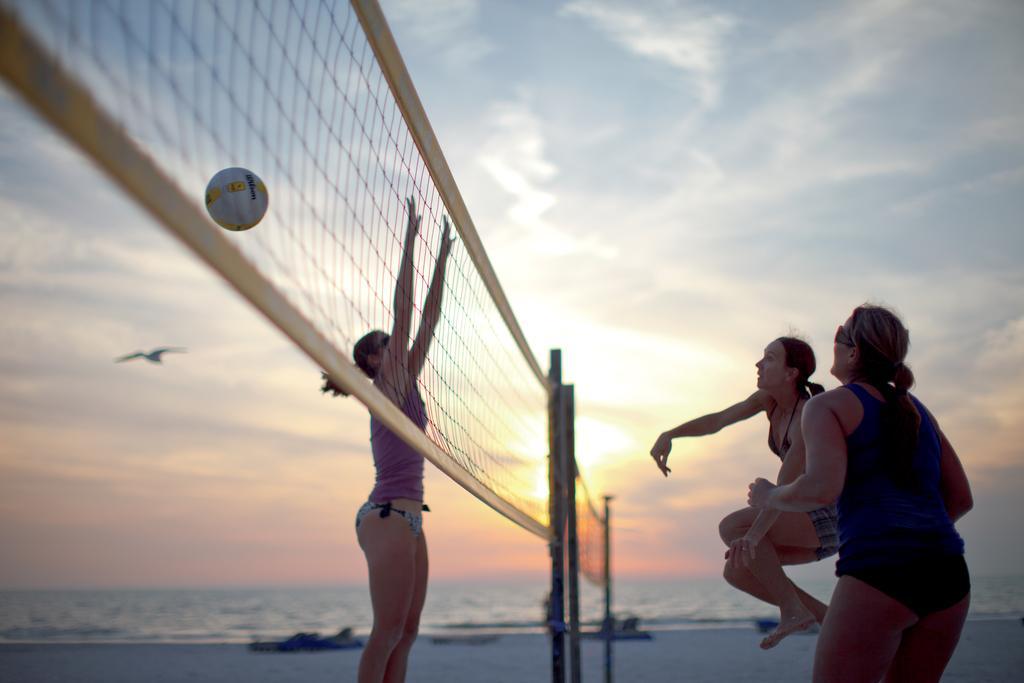How would you summarize this image in a sentence or two? In this image there are three women playing volleyball on the beach side, in the background of the image there is water. 